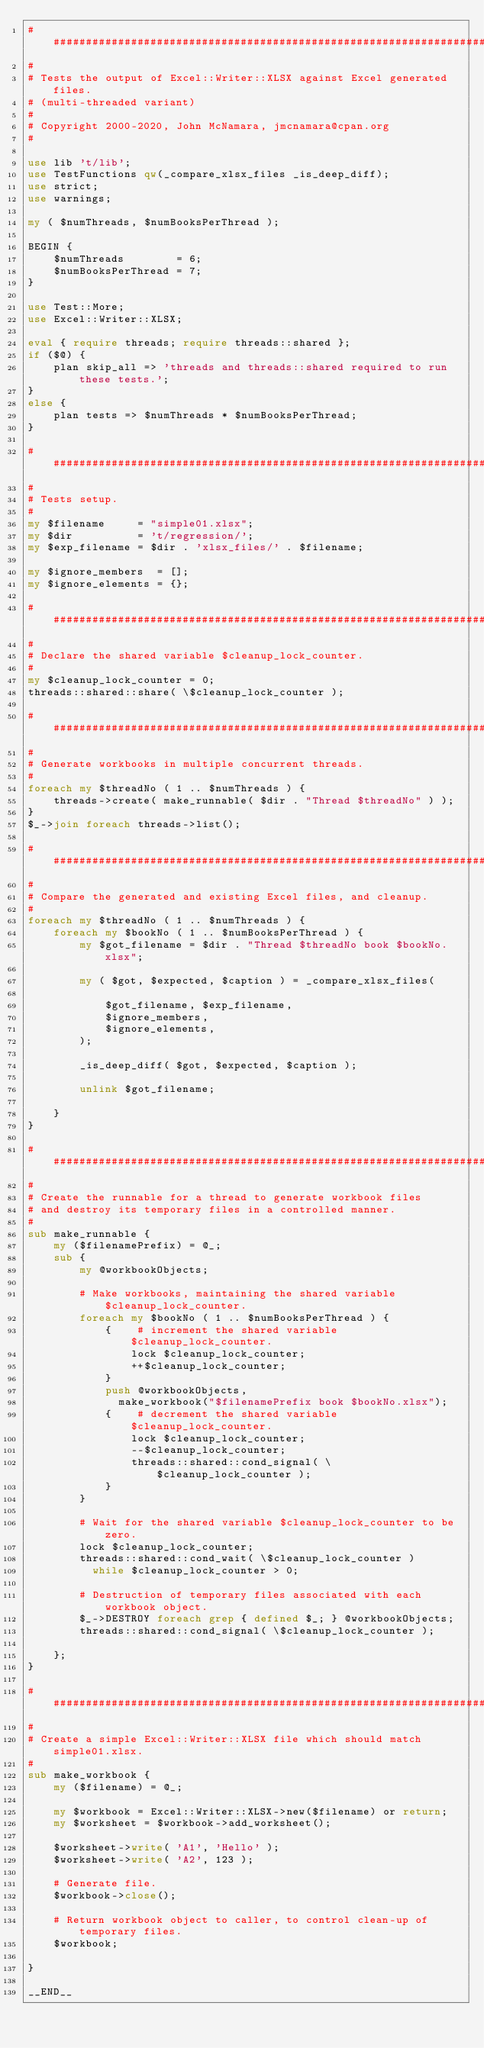Convert code to text. <code><loc_0><loc_0><loc_500><loc_500><_Perl_>###############################################################################
#
# Tests the output of Excel::Writer::XLSX against Excel generated files.
# (multi-threaded variant)
#
# Copyright 2000-2020, John McNamara, jmcnamara@cpan.org
#

use lib 't/lib';
use TestFunctions qw(_compare_xlsx_files _is_deep_diff);
use strict;
use warnings;

my ( $numThreads, $numBooksPerThread );

BEGIN {
    $numThreads        = 6;
    $numBooksPerThread = 7;
}

use Test::More;
use Excel::Writer::XLSX;

eval { require threads; require threads::shared };
if ($@) {
    plan skip_all => 'threads and threads::shared required to run these tests.';
}
else {
    plan tests => $numThreads * $numBooksPerThread;
}

###############################################################################
#
# Tests setup.
#
my $filename     = "simple01.xlsx";
my $dir          = 't/regression/';
my $exp_filename = $dir . 'xlsx_files/' . $filename;

my $ignore_members  = [];
my $ignore_elements = {};

###############################################################################
#
# Declare the shared variable $cleanup_lock_counter.
#
my $cleanup_lock_counter = 0;
threads::shared::share( \$cleanup_lock_counter );

###############################################################################
#
# Generate workbooks in multiple concurrent threads.
#
foreach my $threadNo ( 1 .. $numThreads ) {
    threads->create( make_runnable( $dir . "Thread $threadNo" ) );
}
$_->join foreach threads->list();

###############################################################################
#
# Compare the generated and existing Excel files, and cleanup.
#
foreach my $threadNo ( 1 .. $numThreads ) {
    foreach my $bookNo ( 1 .. $numBooksPerThread ) {
        my $got_filename = $dir . "Thread $threadNo book $bookNo.xlsx";

        my ( $got, $expected, $caption ) = _compare_xlsx_files(

            $got_filename, $exp_filename,
            $ignore_members,
            $ignore_elements,
        );

        _is_deep_diff( $got, $expected, $caption );

        unlink $got_filename;

    }
}

###############################################################################
#
# Create the runnable for a thread to generate workbook files
# and destroy its temporary files in a controlled manner.
#
sub make_runnable {
    my ($filenamePrefix) = @_;
    sub {
        my @workbookObjects;

        # Make workbooks, maintaining the shared variable $cleanup_lock_counter.
        foreach my $bookNo ( 1 .. $numBooksPerThread ) {
            {    # increment the shared variable $cleanup_lock_counter.
                lock $cleanup_lock_counter;
                ++$cleanup_lock_counter;
            }
            push @workbookObjects,
              make_workbook("$filenamePrefix book $bookNo.xlsx");
            {    # decrement the shared variable $cleanup_lock_counter.
                lock $cleanup_lock_counter;
                --$cleanup_lock_counter;
                threads::shared::cond_signal( \$cleanup_lock_counter );
            }
        }

        # Wait for the shared variable $cleanup_lock_counter to be zero.
        lock $cleanup_lock_counter;
        threads::shared::cond_wait( \$cleanup_lock_counter )
          while $cleanup_lock_counter > 0;

        # Destruction of temporary files associated with each workbook object.
        $_->DESTROY foreach grep { defined $_; } @workbookObjects;
        threads::shared::cond_signal( \$cleanup_lock_counter );

    };
}

###############################################################################
#
# Create a simple Excel::Writer::XLSX file which should match simple01.xlsx.
#
sub make_workbook {
    my ($filename) = @_;

    my $workbook = Excel::Writer::XLSX->new($filename) or return;
    my $worksheet = $workbook->add_worksheet();

    $worksheet->write( 'A1', 'Hello' );
    $worksheet->write( 'A2', 123 );

    # Generate file.
    $workbook->close();

    # Return workbook object to caller, to control clean-up of temporary files.
    $workbook;

}

__END__
</code> 